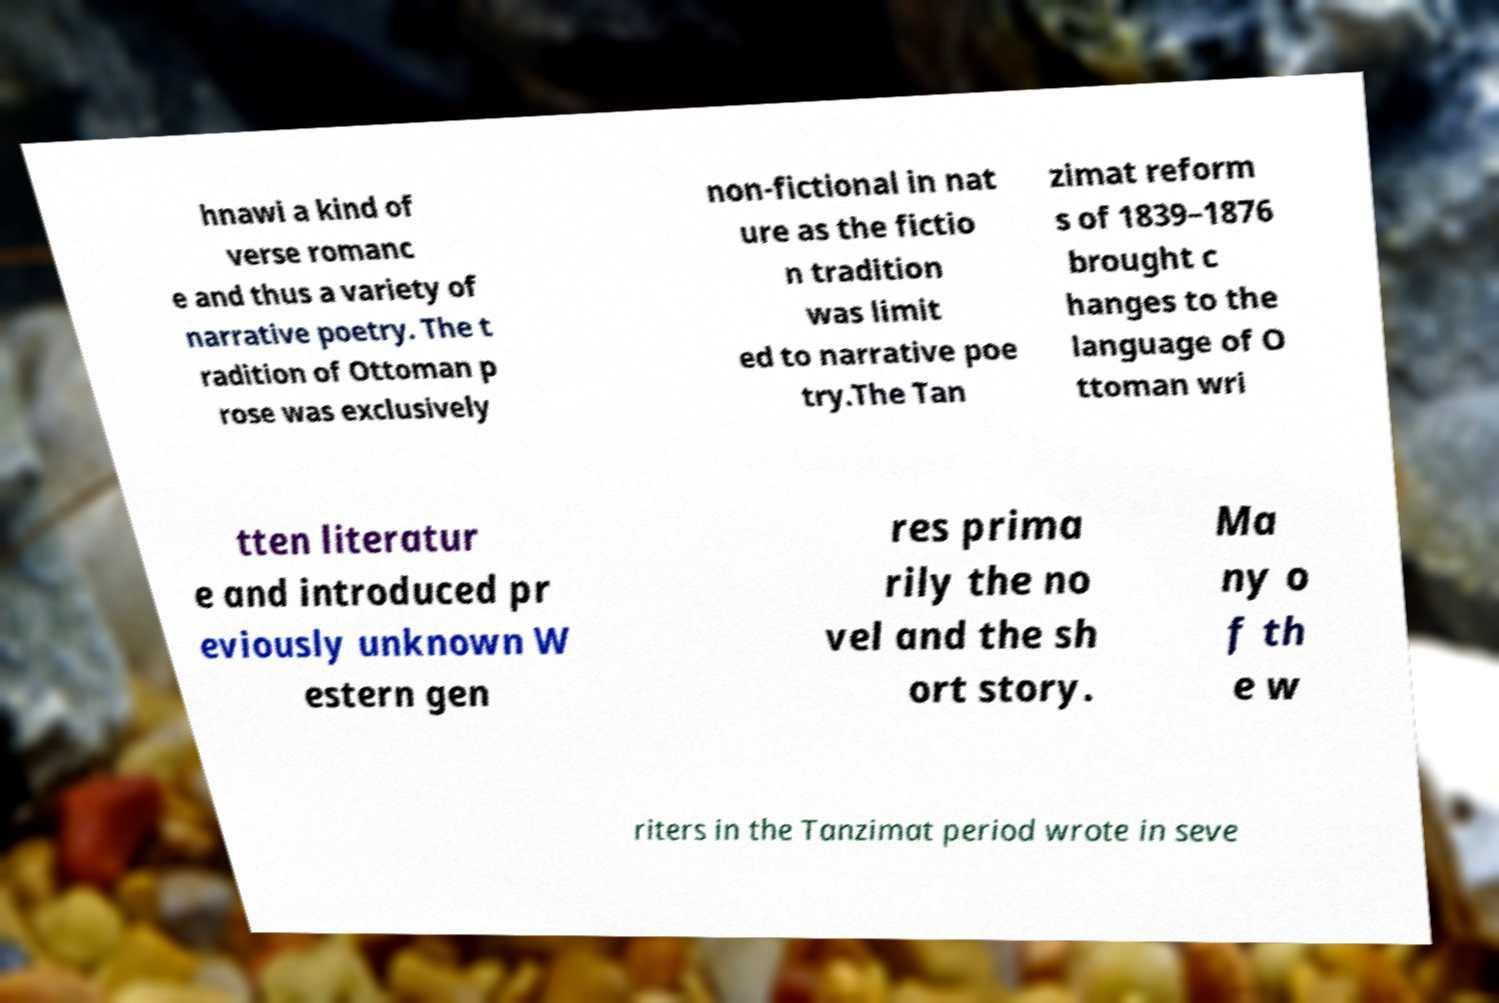Could you extract and type out the text from this image? hnawi a kind of verse romanc e and thus a variety of narrative poetry. The t radition of Ottoman p rose was exclusively non-fictional in nat ure as the fictio n tradition was limit ed to narrative poe try.The Tan zimat reform s of 1839–1876 brought c hanges to the language of O ttoman wri tten literatur e and introduced pr eviously unknown W estern gen res prima rily the no vel and the sh ort story. Ma ny o f th e w riters in the Tanzimat period wrote in seve 